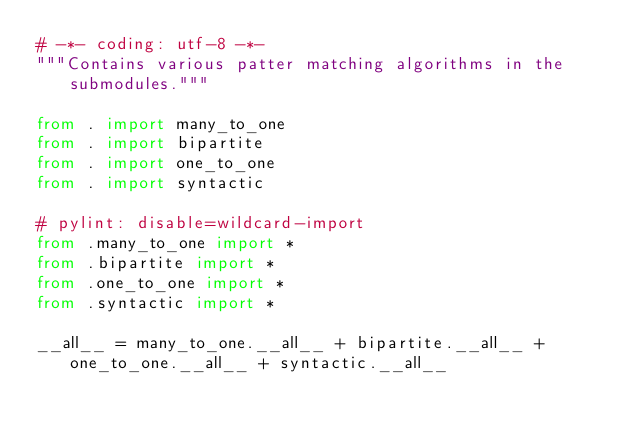<code> <loc_0><loc_0><loc_500><loc_500><_Python_># -*- coding: utf-8 -*-
"""Contains various patter matching algorithms in the submodules."""

from . import many_to_one
from . import bipartite
from . import one_to_one
from . import syntactic

# pylint: disable=wildcard-import
from .many_to_one import *
from .bipartite import *
from .one_to_one import *
from .syntactic import *

__all__ = many_to_one.__all__ + bipartite.__all__ + one_to_one.__all__ + syntactic.__all__
</code> 